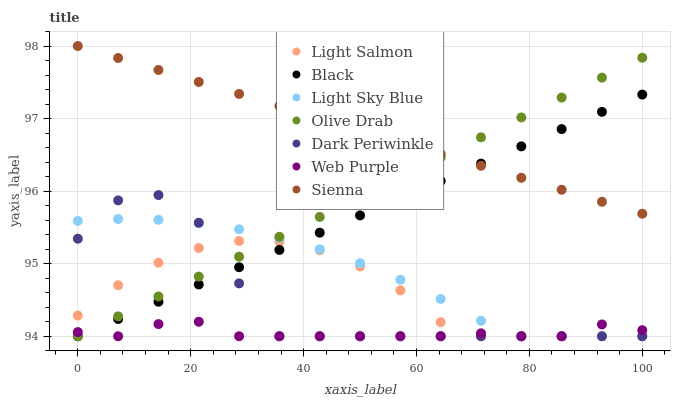Does Web Purple have the minimum area under the curve?
Answer yes or no. Yes. Does Sienna have the maximum area under the curve?
Answer yes or no. Yes. Does Sienna have the minimum area under the curve?
Answer yes or no. No. Does Web Purple have the maximum area under the curve?
Answer yes or no. No. Is Olive Drab the smoothest?
Answer yes or no. Yes. Is Dark Periwinkle the roughest?
Answer yes or no. Yes. Is Sienna the smoothest?
Answer yes or no. No. Is Sienna the roughest?
Answer yes or no. No. Does Light Salmon have the lowest value?
Answer yes or no. Yes. Does Sienna have the lowest value?
Answer yes or no. No. Does Sienna have the highest value?
Answer yes or no. Yes. Does Web Purple have the highest value?
Answer yes or no. No. Is Light Salmon less than Sienna?
Answer yes or no. Yes. Is Sienna greater than Light Salmon?
Answer yes or no. Yes. Does Light Sky Blue intersect Olive Drab?
Answer yes or no. Yes. Is Light Sky Blue less than Olive Drab?
Answer yes or no. No. Is Light Sky Blue greater than Olive Drab?
Answer yes or no. No. Does Light Salmon intersect Sienna?
Answer yes or no. No. 